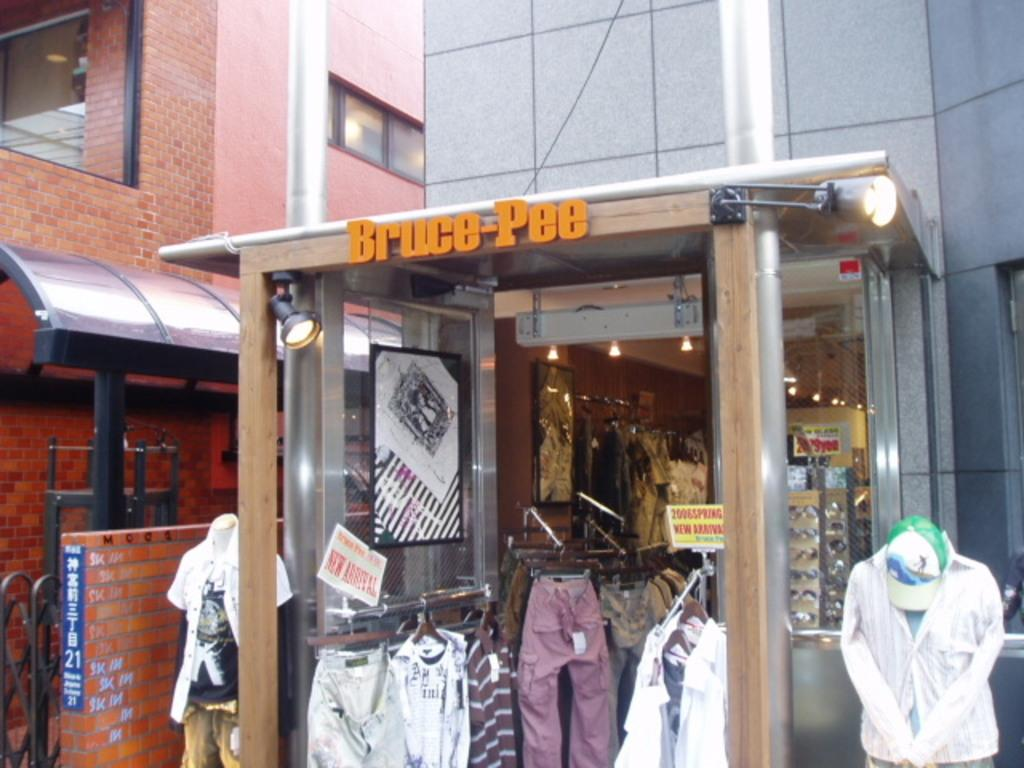<image>
Render a clear and concise summary of the photo. a clothes stall called Bruce-pee with trousers and jackets displayed 